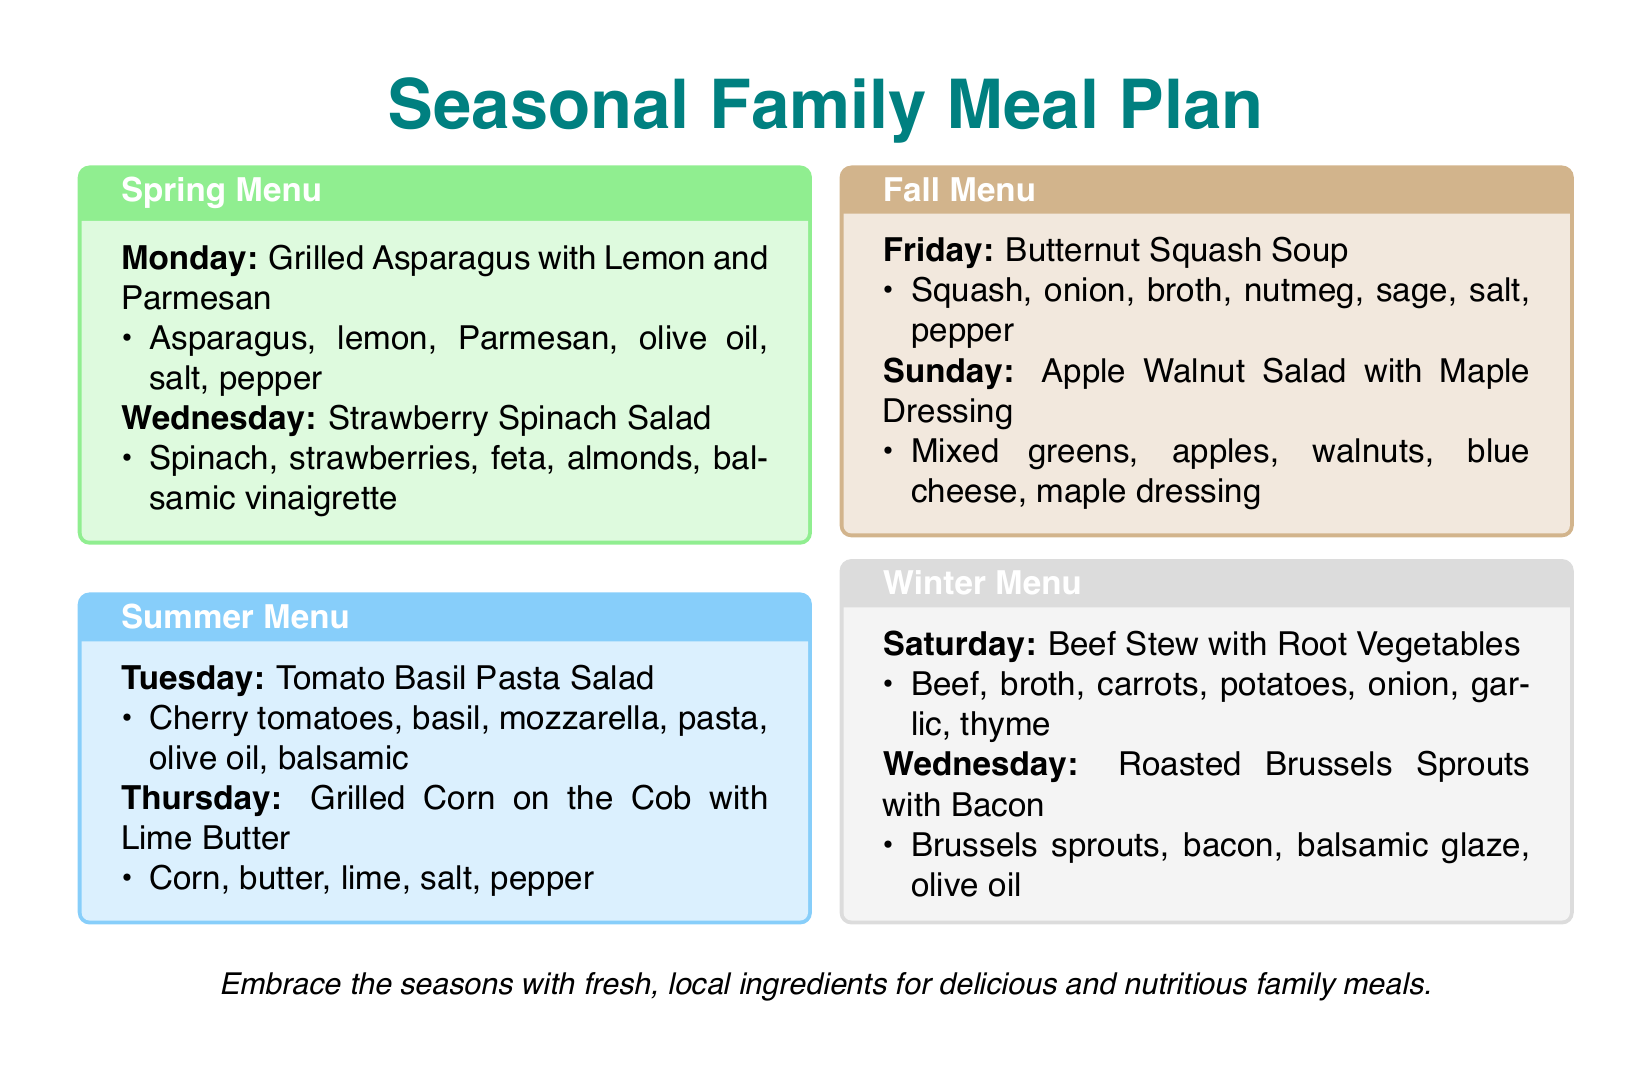What is the header title of the document? The header title is prominently displayed at the top of the document, stating the purpose of the meal plan.
Answer: Seasonal Family Meal Plan Which day features Grilled Asparagus with Lemon and Parmesan? The specific day for this recipe is indicated within the Spring Menu section of the document.
Answer: Monday What is included in the Strawberry Spinach Salad? The items are listed under the Spring Menu, providing details about the ingredients.
Answer: Spinach, strawberries, feta, almonds, balsamic vinaigrette How many menus are presented in the document? The document outlines distinct menus for each of the four seasons, demonstrating the variety available.
Answer: Four What is the main ingredient in the Butternut Squash Soup? This information is highlighted within the context of the Fall Menu, specifying the primary component of the dish.
Answer: Squash On which day is the Beef Stew served? The document specifies the day allocated for this meal in the Winter Menu section.
Answer: Saturday What is the color theme of the Summer Menu box? Each season has a designated color for its menu box, reflecting its theme.
Answer: summerblue Which ingredient is used for the Maple Dressing? The ingredients for the Apple Walnut Salad are detailed, including the dressing.
Answer: Maple dressing 